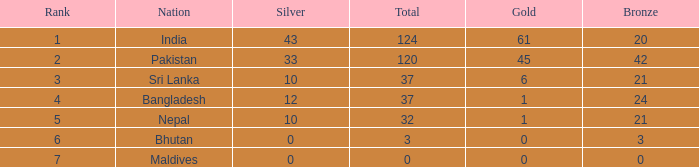In sri lanka, which gold is accompanied by a silver less than 10? None. 